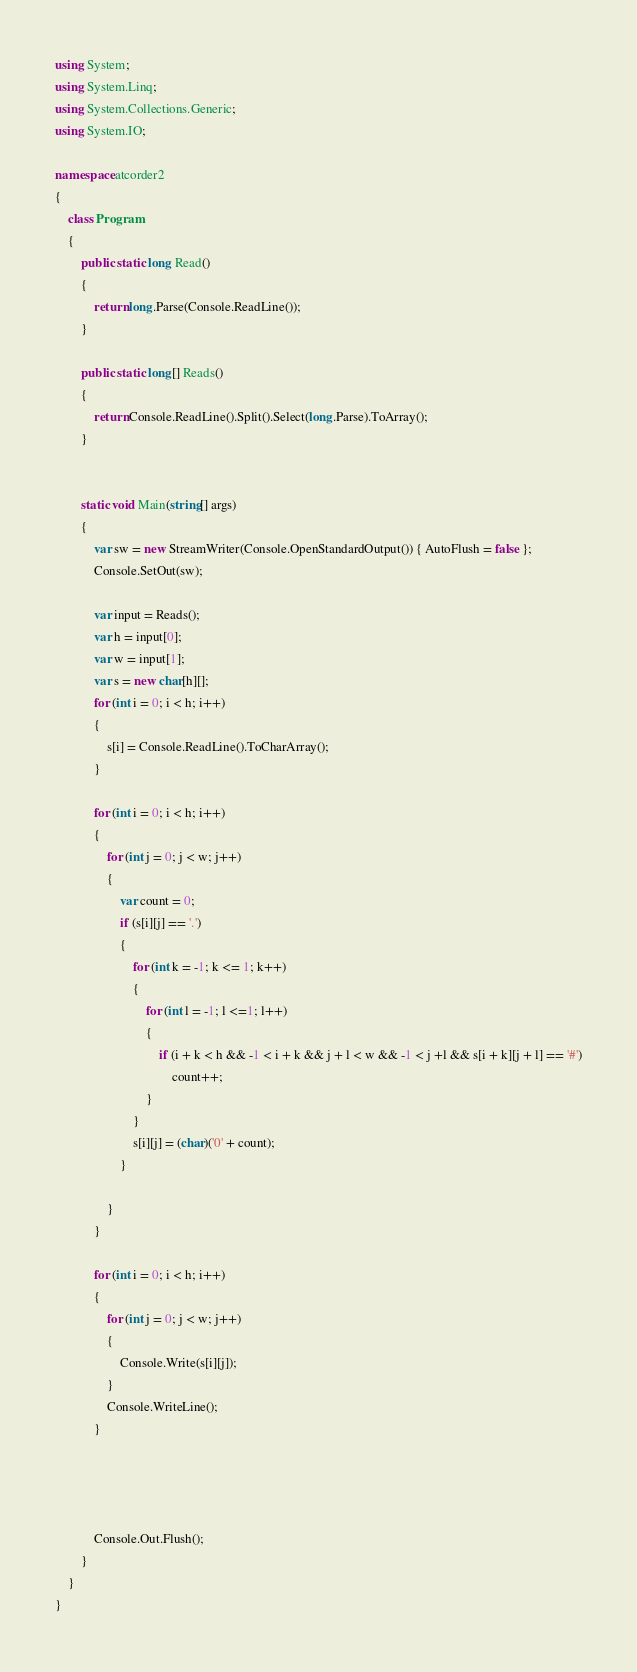Convert code to text. <code><loc_0><loc_0><loc_500><loc_500><_C#_>using System;
using System.Linq;
using System.Collections.Generic;
using System.IO;

namespace atcorder2
{
    class Program
    {
        public static long Read()
        {
            return long.Parse(Console.ReadLine());
        }

        public static long[] Reads()
        {
            return Console.ReadLine().Split().Select(long.Parse).ToArray();
        }

        
        static void Main(string[] args)
        {
            var sw = new StreamWriter(Console.OpenStandardOutput()) { AutoFlush = false };
            Console.SetOut(sw);

            var input = Reads();
            var h = input[0];
            var w = input[1];
            var s = new char[h][];
            for (int i = 0; i < h; i++)
            {
                s[i] = Console.ReadLine().ToCharArray();
            }
       
            for (int i = 0; i < h; i++)
            {
                for (int j = 0; j < w; j++)
                {
                    var count = 0;
                    if (s[i][j] == '.')
                    {
                        for (int k = -1; k <= 1; k++)
                        {
                            for (int l = -1; l <=1; l++)
                            {
                                if (i + k < h && -1 < i + k && j + l < w && -1 < j +l && s[i + k][j + l] == '#')
                                    count++;
                            }
                        }
                        s[i][j] = (char)('0' + count);
                    }
                    
                }
            }

            for (int i = 0; i < h; i++)
            {
                for (int j = 0; j < w; j++)
                { 
                    Console.Write(s[i][j]);
                }
                Console.WriteLine();
            }
            
         


            Console.Out.Flush();
        }
    }
}
</code> 